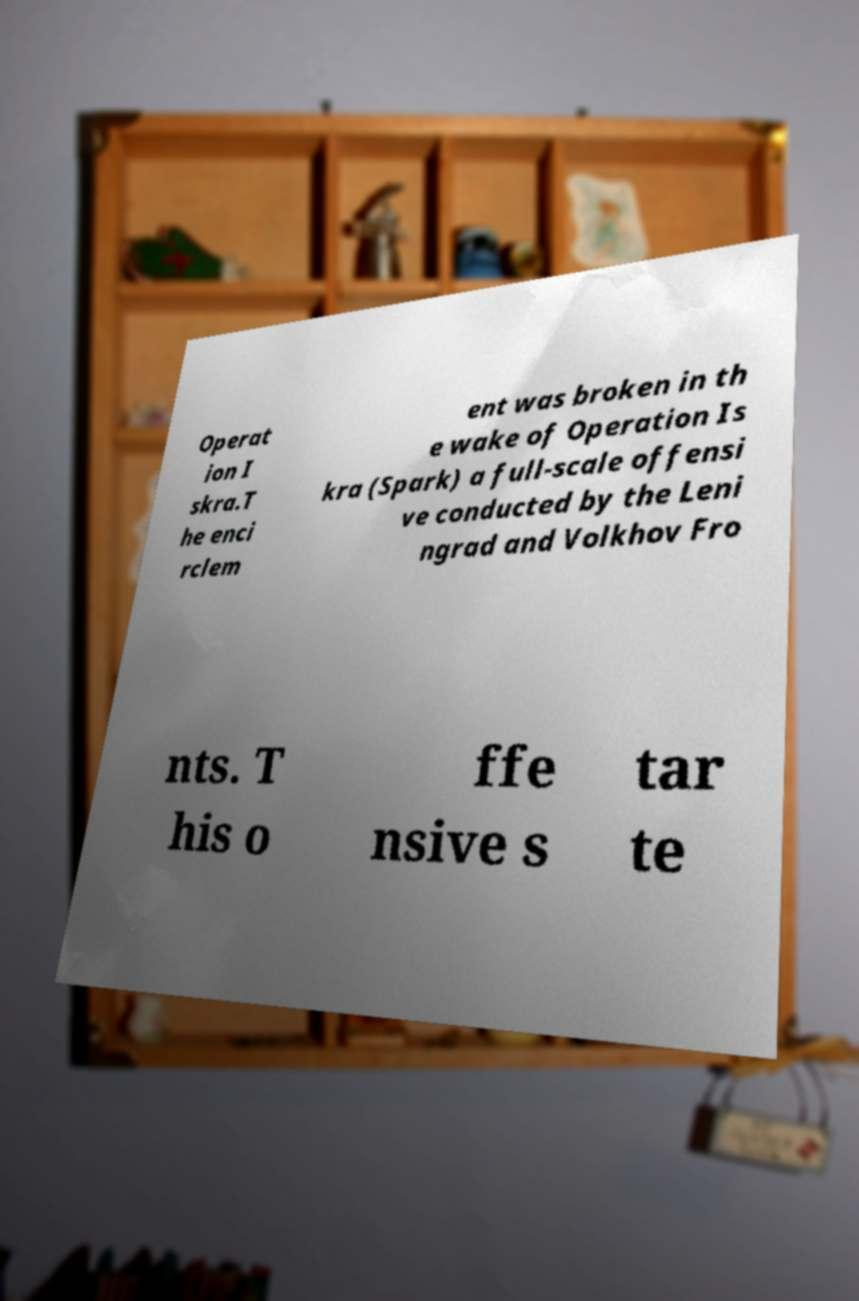What messages or text are displayed in this image? I need them in a readable, typed format. Operat ion I skra.T he enci rclem ent was broken in th e wake of Operation Is kra (Spark) a full-scale offensi ve conducted by the Leni ngrad and Volkhov Fro nts. T his o ffe nsive s tar te 